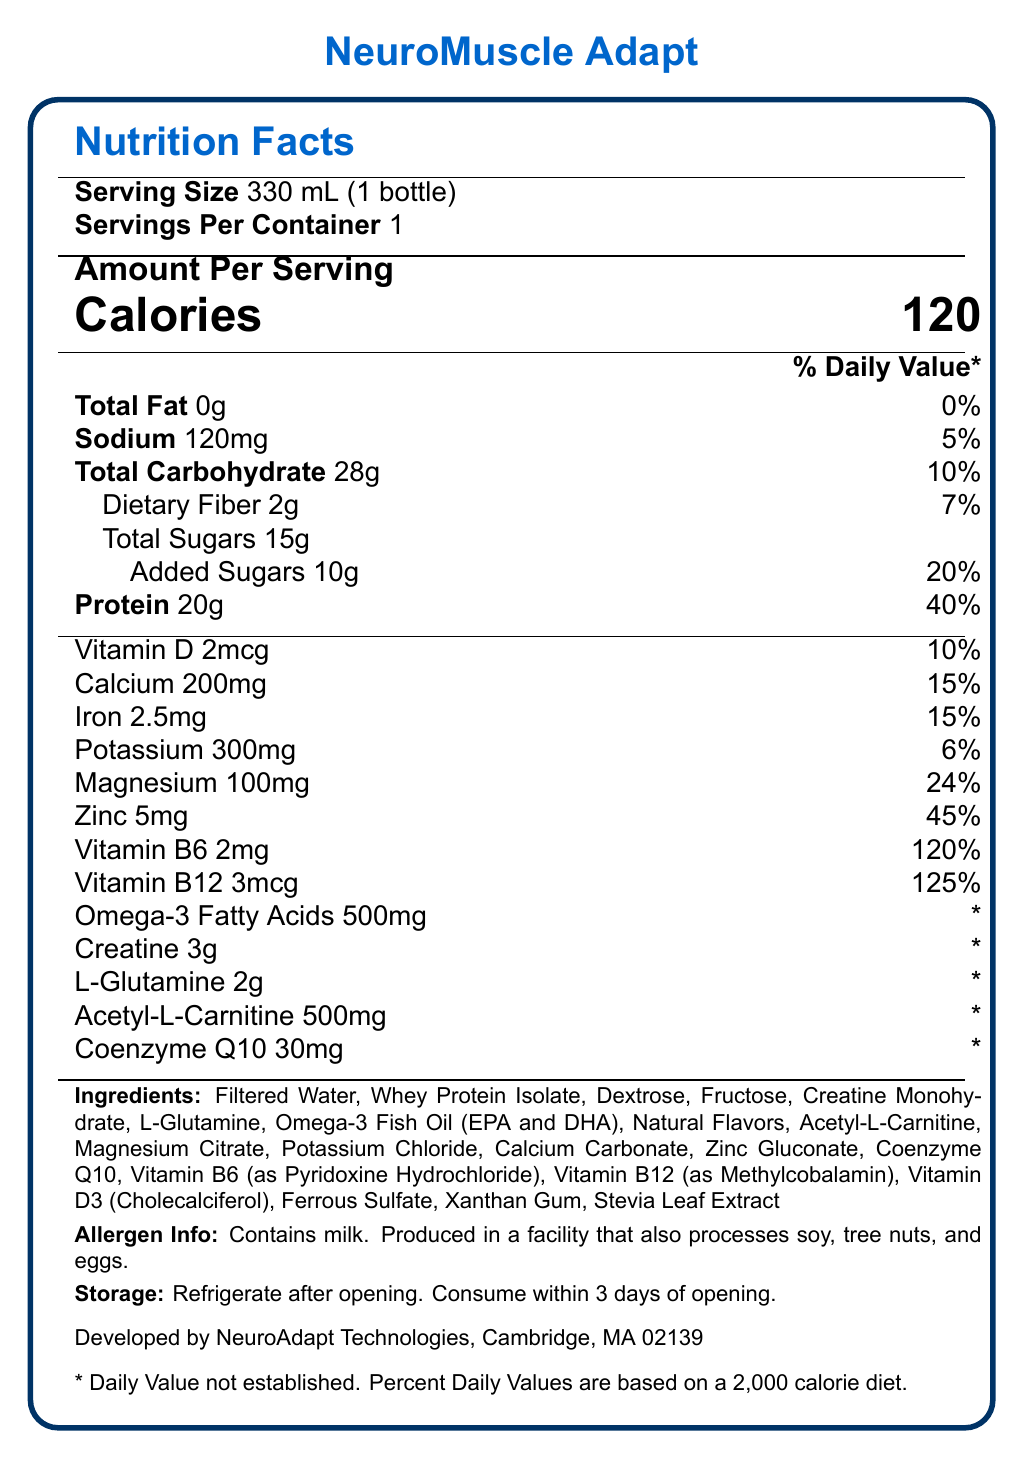What is the serving size for NeuroMuscle Adapt? The serving size is clearly listed at the top of the featured information on the label as "330 mL (1 bottle)."
Answer: 330 mL (1 bottle) How many grams of protein does one serving contain? Under the 'Amount Per Serving' section, protein is listed as having 20 grams per serving.
Answer: 20g What is the percentage of the daily value for calcium in this beverage? In the section after protein, calcium is listed with its daily value percentage as 15%.
Answer: 15% What is the total carbohydrate content per serving? Total carbohydrate content per serving is shown as 28 grams in the 'Amount Per Serving' section.
Answer: 28g How much creatine is there per serving? Creatine is listed under the main nutrient section with an amount of 3 grams per serving.
Answer: 3g Which ingredient is listed first in the ingredients list? The ingredients list starts with "Filtered Water" as the first ingredient.
Answer: Filtered Water Which nutrient has the highest percentage of the daily value per serving? A. Vitamin D B. Zinc C. Vitamin B6 D. Calcium Among the listed nutrients, Vitamin B6 has the highest daily value percentage at 120%.
Answer: C. Vitamin B6 How many grams of added sugars are in one serving? A. 2g B. 5g C. 10g D. 15g The label under Total Sugars specifies that there are 10 grams of added sugars per serving.
Answer: C. 10g Does this beverage contain any milk? The allergen information section states that the product contains milk.
Answer: Yes What are the storage instructions for the NeuroMuscle Adapt beverage? The storage instructions are provided at the bottom of the label and indicate that the beverage should be refrigerated after opening and consumed within 3 days.
Answer: Refrigerate after opening. Consume within 3 days of opening. Who is the manufacturer of NeuroMuscle Adapt? The manufacturer information is located at the bottom and specifies NeuroAdapt Technologies in Cambridge, MA 02139.
Answer: NeuroAdapt Technologies, Cambridge, MA 02139 Does the label provide a daily value percentage for Omega-3 Fatty Acids? The daily value percentage for Omega-3 Fatty Acids is marked with an asterisk (*) indicating it is not established.
Answer: No Summarize the information presented in this Nutrition Facts Label. The label is comprehensive, offering information crucial for consumers concerned about nutritional intake and specific health benefits such as muscle adaptation and pain reduction.
Answer: The Nutrition Facts Label for NeuroMuscle Adapt, a fortified beverage aimed at improving muscle adaptation and reducing phantom limb pain, provides detailed information about serving size, calorie content, macronutrients (total fat, sodium, carbohydrates, protein), and micronutrients (various vitamins and minerals). It lists the percentage of daily values and highlights special ingredients targeted at muscle health such as creatine, L-glutamine, and omega-3 fatty acids. There's also allergen information, storage instructions, and manufacturer details. To improve muscle adaptation and reduce phantom limb pain, how is L-Glutamine beneficial? The provided Nutrition Facts Label does not describe how L-Glutamine specifically aids in muscle adaptation or phantom limb pain, thus this information cannot be determined from the document.
Answer: Not enough information 